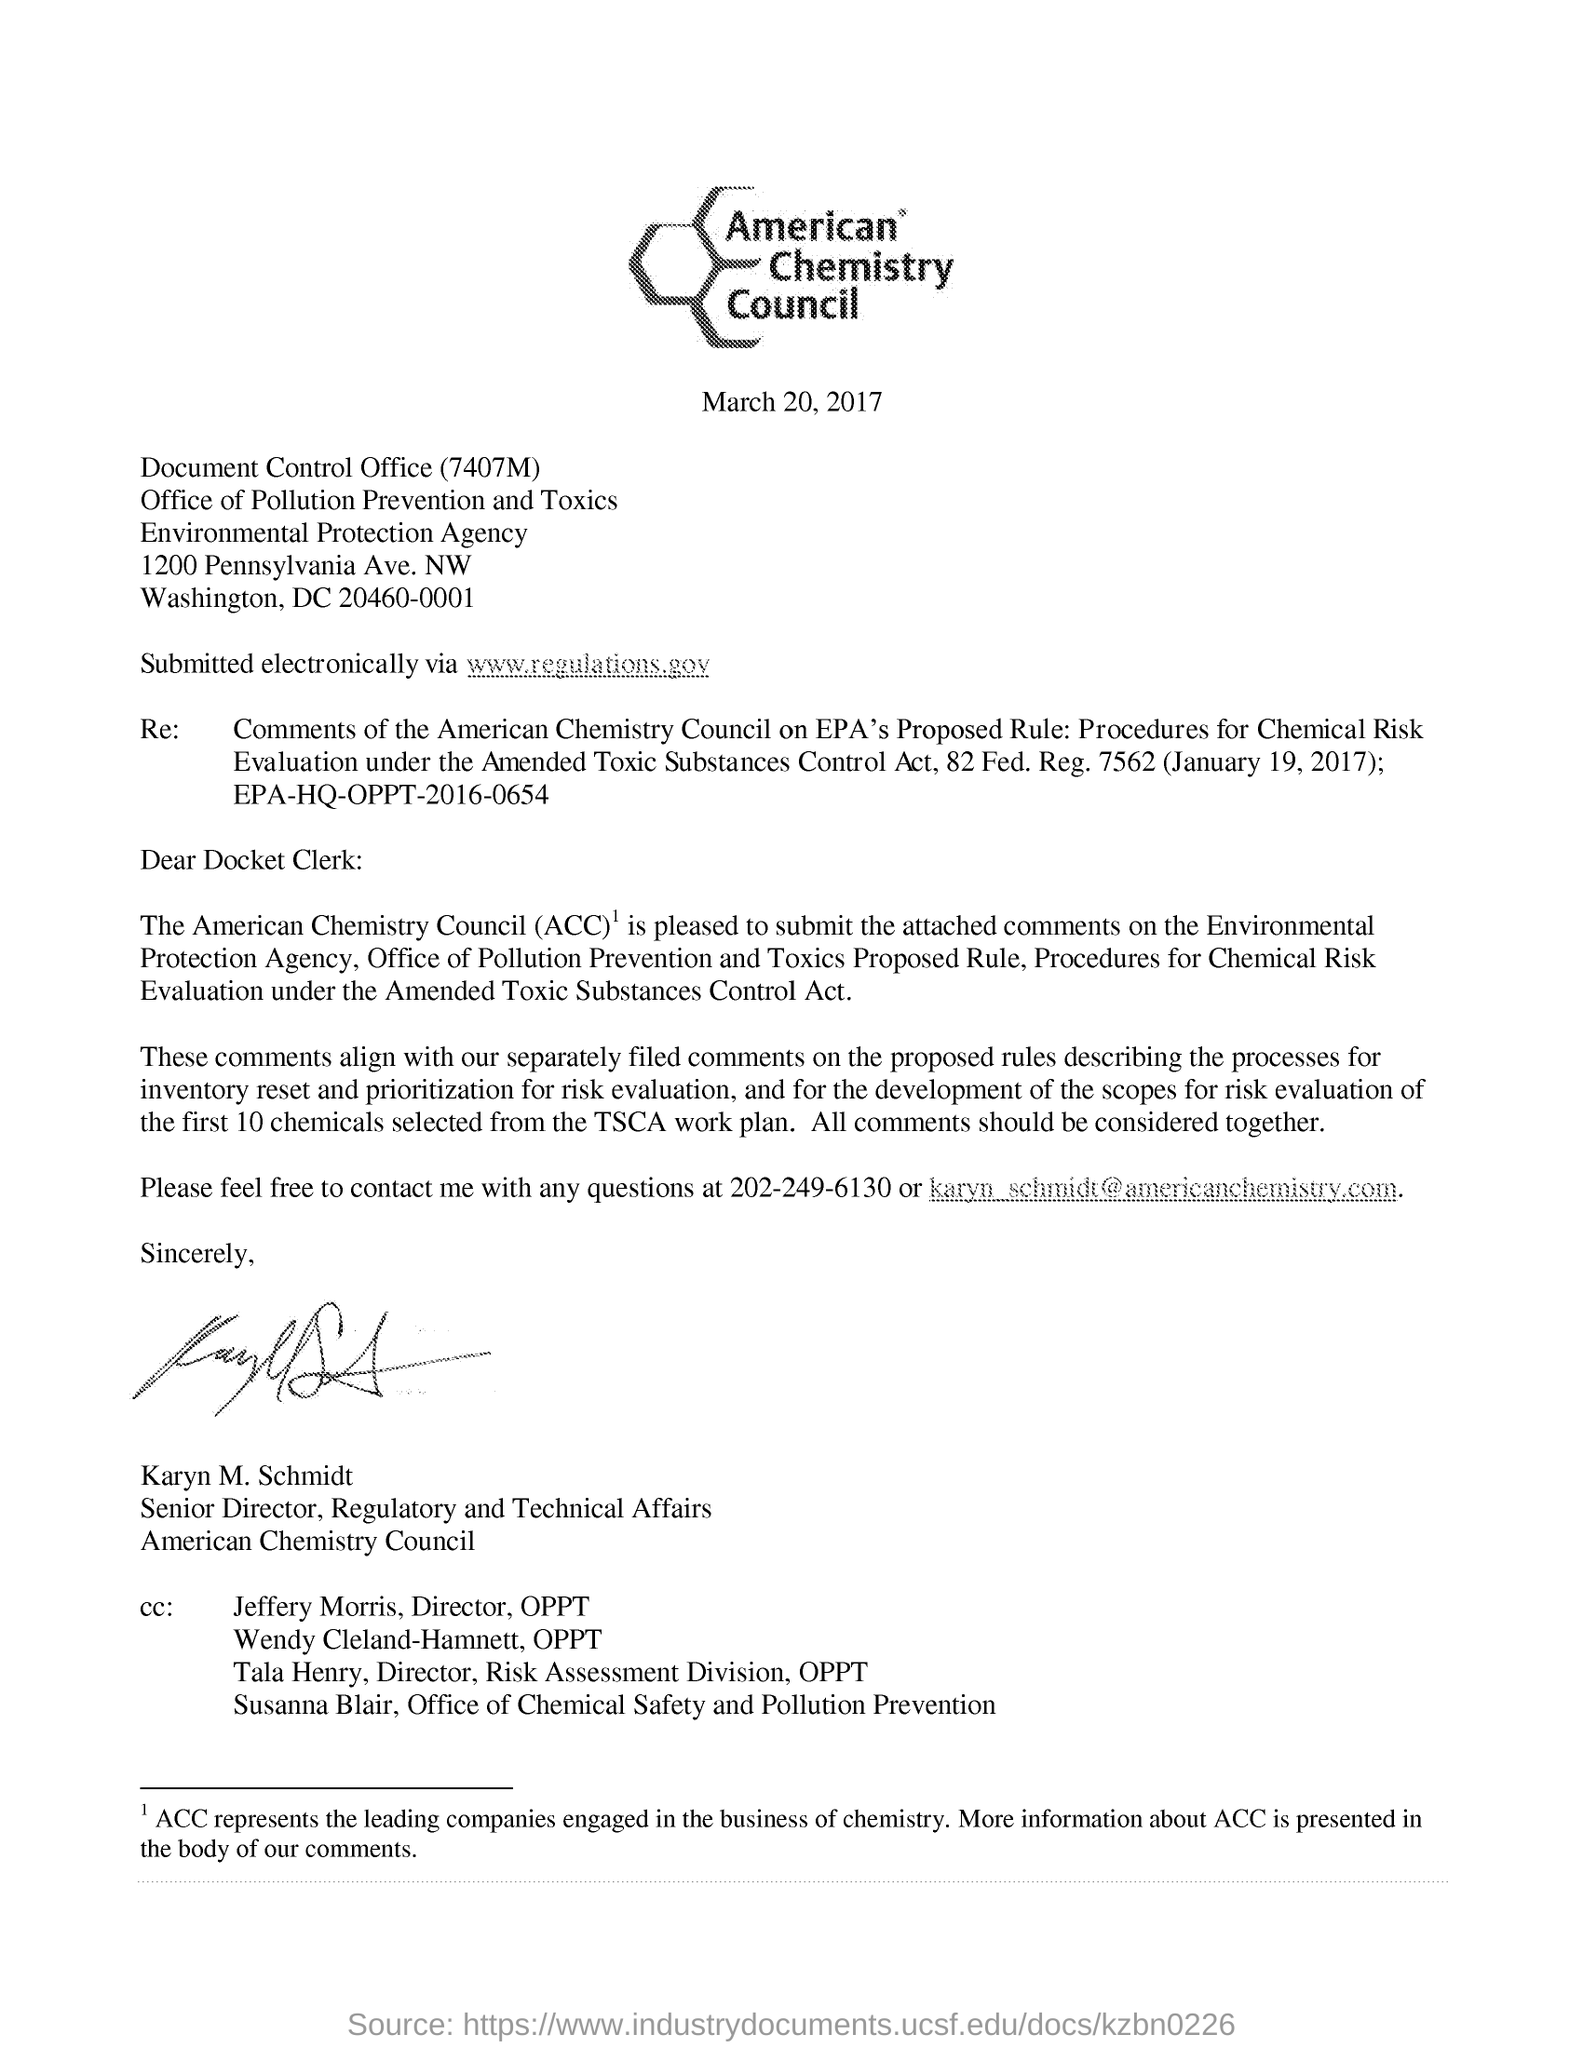what is the regulation for amended toxic substances control act? The Amended Toxic Substances Control Act (TSCA) is the United States' primary chemicals management law. The 2016 amendments to TSCA, also known as the Frank R. Lautenberg Chemical Safety for the 21st Century Act, require the Environmental Protection Agency (EPA) to evaluate existing chemicals for safety at a pace of at least 20 chemicals at a time and to determine whether they present an unreasonable risk to humans or the environment. This process involves risk evaluation, regulation, and in some cases, the banning or restricting of certain chemicals deemed hazardous. The letter shown in the image likely pertains to comments submitted by the American Chemistry Council on the EPA's proposed rule regarding the procedures for chemical risk evaluation under the amended TSCA. 